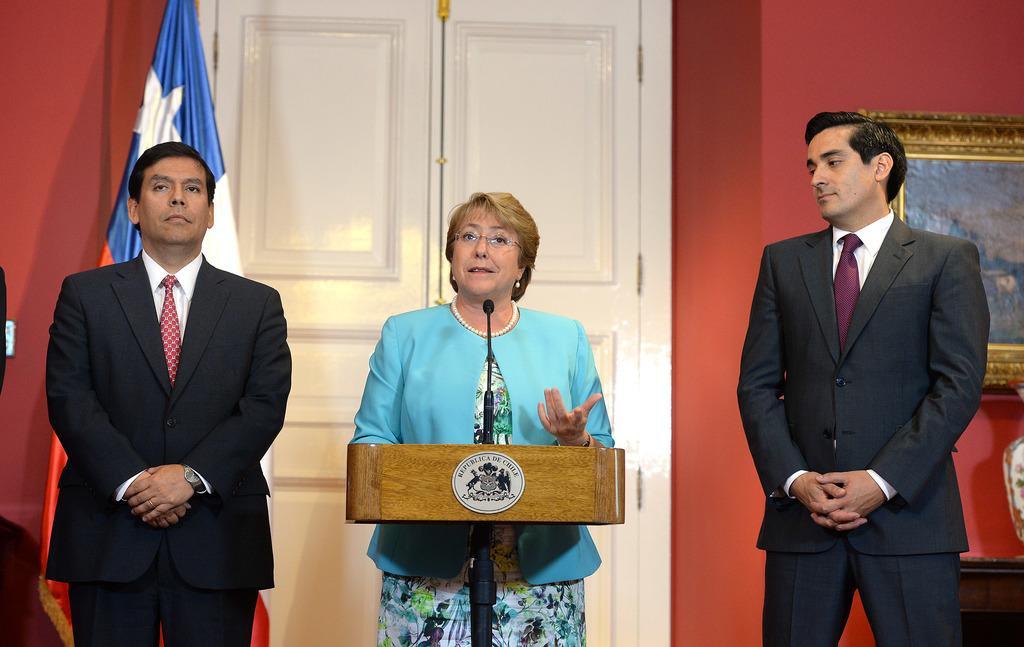Could you give a brief overview of what you see in this image? In this picture there is a lady in the center of the image in front of a mic and there are two men on the right and left side of the image, there is a door behind her and there is a flag and a portrait in the background area of the image. 